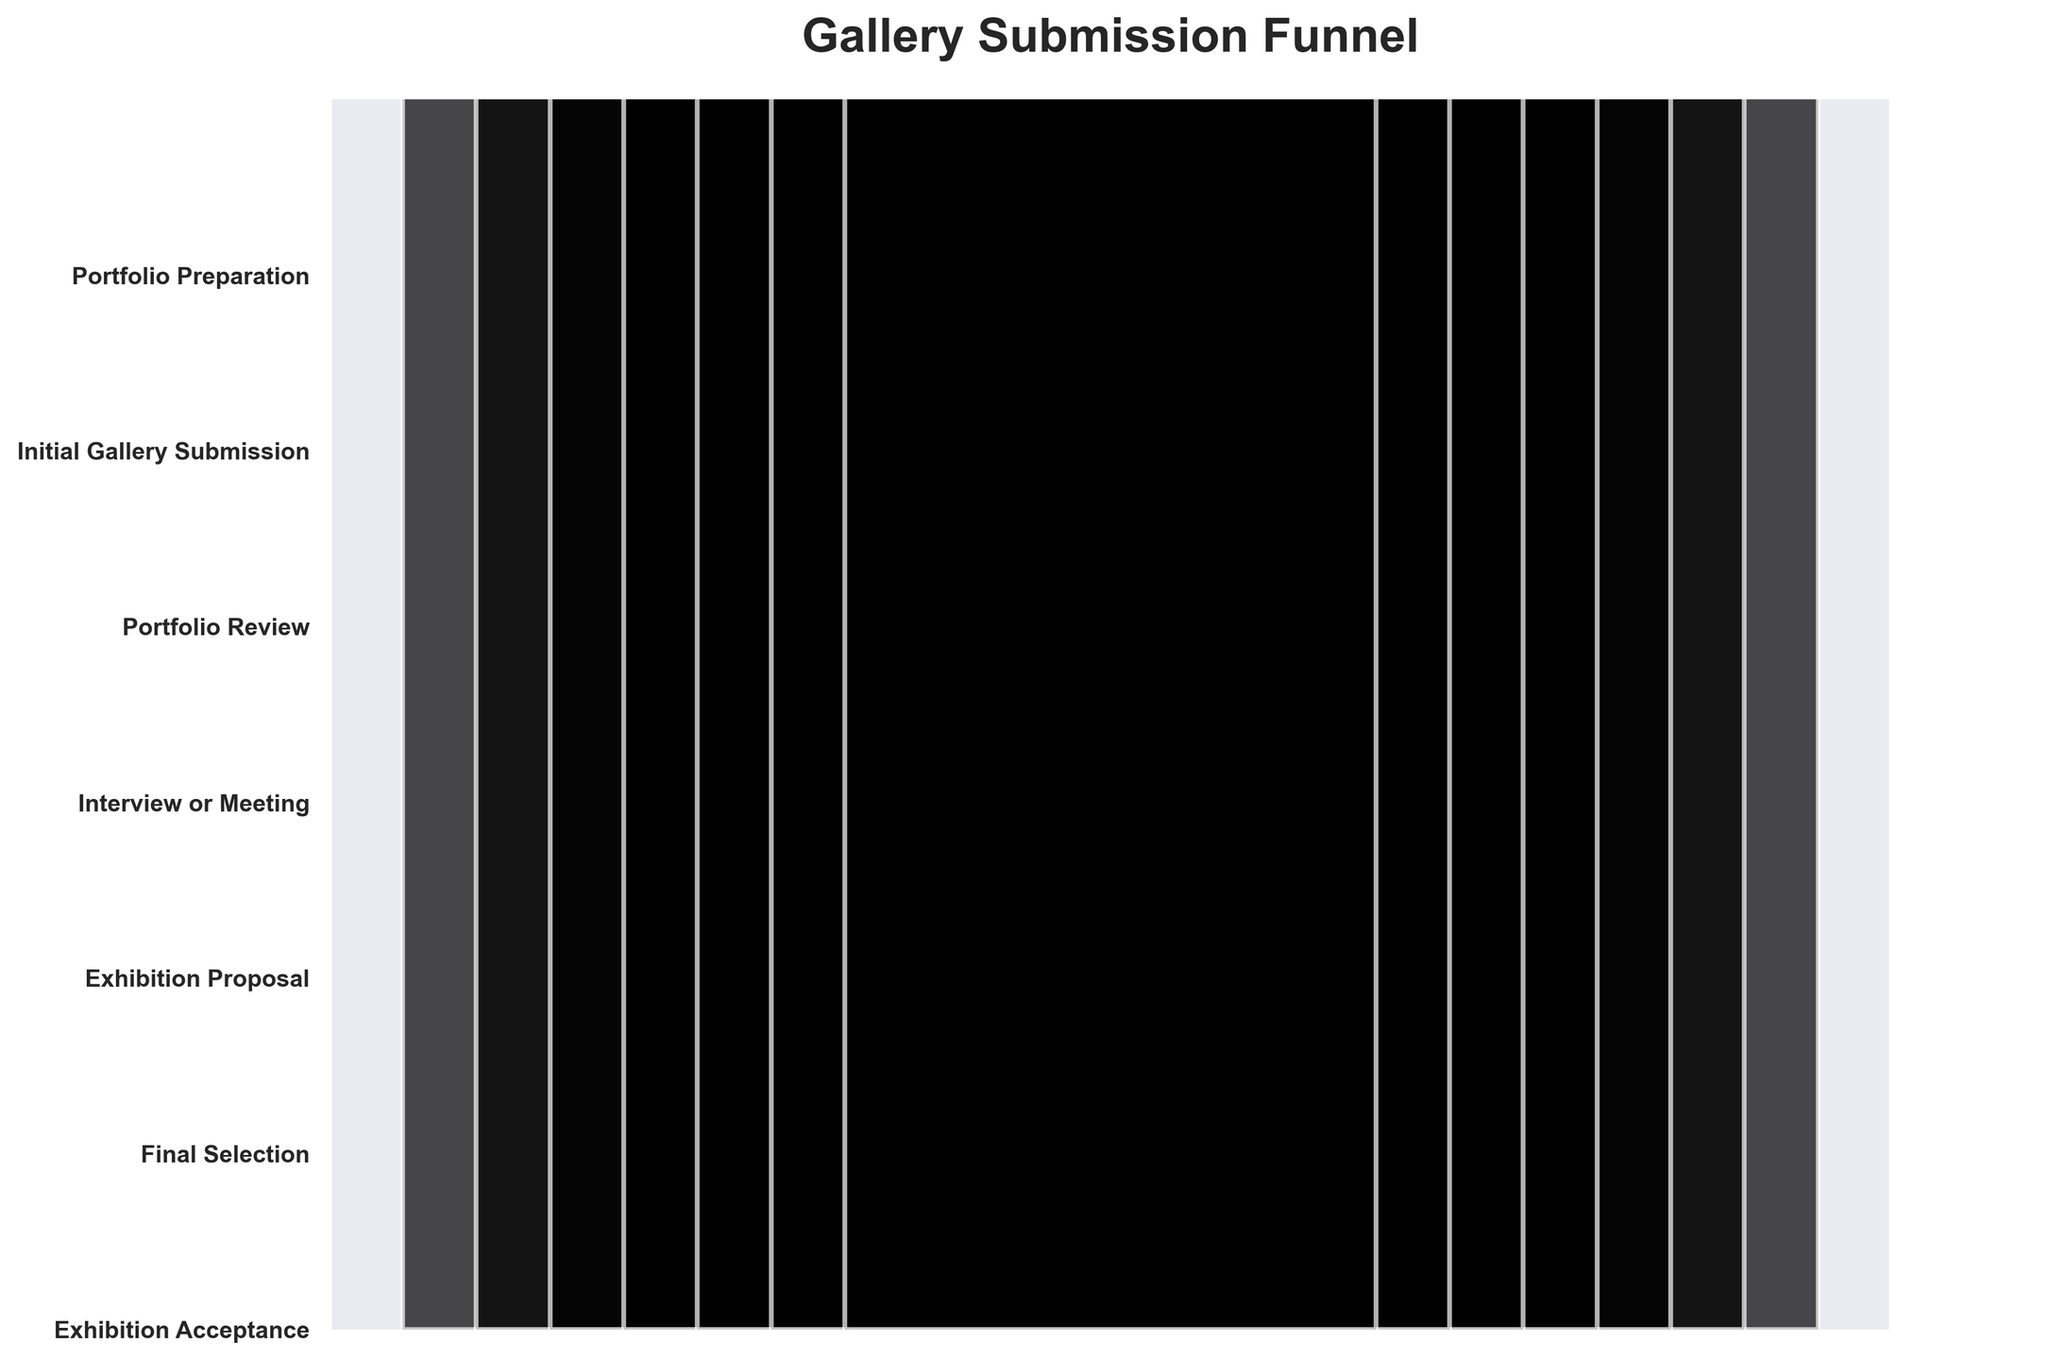1. What is the title of the chart? The title of the chart is typically located at the top of the figure in larger and bold font. Based on this, you can see the chart title.
Answer: Gallery Submission Funnel 2. How many stages are there in the gallery submission process? Count the number of unique stages listed on the y-axis.
Answer: 7 3. What is the number of photographers at the Initial Gallery Submission stage? Locate the "Initial Gallery Submission" label on the y-axis and find the corresponding value.
Answer: 750 4. How many photographers were accepted for an exhibition? Locate the "Exhibition Acceptance" label on the y-axis and find the corresponding value.
Answer: 25 5. Which stage has the highest number of photographers? Compare the values associated with each stage and identify the highest one.
Answer: Portfolio Preparation 6. What is the difference in the number of photographers between the Portfolio Review and Final Selection stages? Find the values for the "Portfolio Review" and "Final Selection" stages and subtract the latter from the former: 500 - 50.
Answer: 450 7. How many photographers progressed from the Interview or Meeting stage to the Exhibition Proposal stage? Locate the values for the "Interview or Meeting" and "Exhibition Proposal" stages, then subtract the latter from the former: 200 - 100.
Answer: 100 8. What proportion of photographers submitted an initial gallery submission out of those who prepared a portfolio? Divide the number at the Initial Gallery Submission stage by the number at the Portfolio Preparation stage and multiply by 100: (750 / 1000) * 100.
Answer: 75% 9. At which stage do we first see a reduction of 500 or more photographers? Examine each stage starting from "Portfolio Preparation" and find when the reduction compared to the previous stage is 500 or more. The first large drop happens between "Initial Gallery Submission" and "Portfolio Review" (1000-750). The exact number starts from "Initial Gallery Submission" reducing to "Portfolio Review" which is 500 or more
Answer: Initial Gallery Submission to Portfolio Review 10. Which stage shows the smallest decrease in the number of photographers from the previous stage? Calculate the change between successive stages and identify the smallest decrease: 
    * Portfolio Preparation to Initial Gallery Submission: 1000 - 750 = 250
    * Initial Gallery Submission to Portfolio Review: 750 - 500 = 250
    * Portfolio Review to Interview or Meeting: 500 - 200 = 300
    * Interview or Meeting to Exhibition Proposal: 200 - 100 = 100
    * Exhibition Proposal to Final Selection: 100 - 50 = 50
    * Final Selection to Exhibition Acceptance: 50 - 25 = 25.
Answer: Final Selection to Exhibition Acceptance 